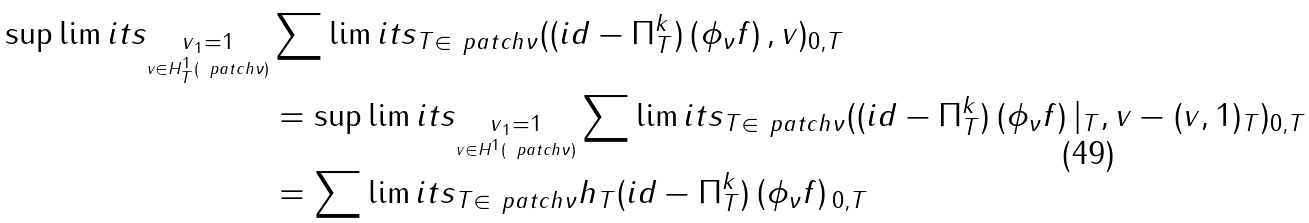<formula> <loc_0><loc_0><loc_500><loc_500>\sup \lim i t s _ { \underset { v \in H ^ { 1 } _ { T } ( \ p a t c h { \nu } ) } { \| v \| _ { 1 } = 1 } } & \sum \lim i t s _ { T \in \ p a t c h { \nu } } ( ( i d - \Pi ^ { k } _ { T } ) \left ( \phi _ { \nu } f \right ) , v ) _ { 0 , T } \\ & = \sup \lim i t s _ { \underset { v \in H ^ { 1 } ( \ p a t c h { \nu } ) } { \| v \| _ { 1 } = 1 } } \sum \lim i t s _ { T \in \ p a t c h { \nu } } ( ( i d - \Pi ^ { k } _ { T } ) \left ( \phi _ { \nu } f \right ) | _ { T } , v - ( v , 1 ) _ { T } ) _ { 0 , T } \\ & = \sum \lim i t s _ { T \in \ p a t c h { \nu } } \| h _ { T } ( i d - \Pi ^ { k } _ { T } ) \left ( \phi _ { \nu } f \right ) \| _ { 0 , T } \\</formula> 